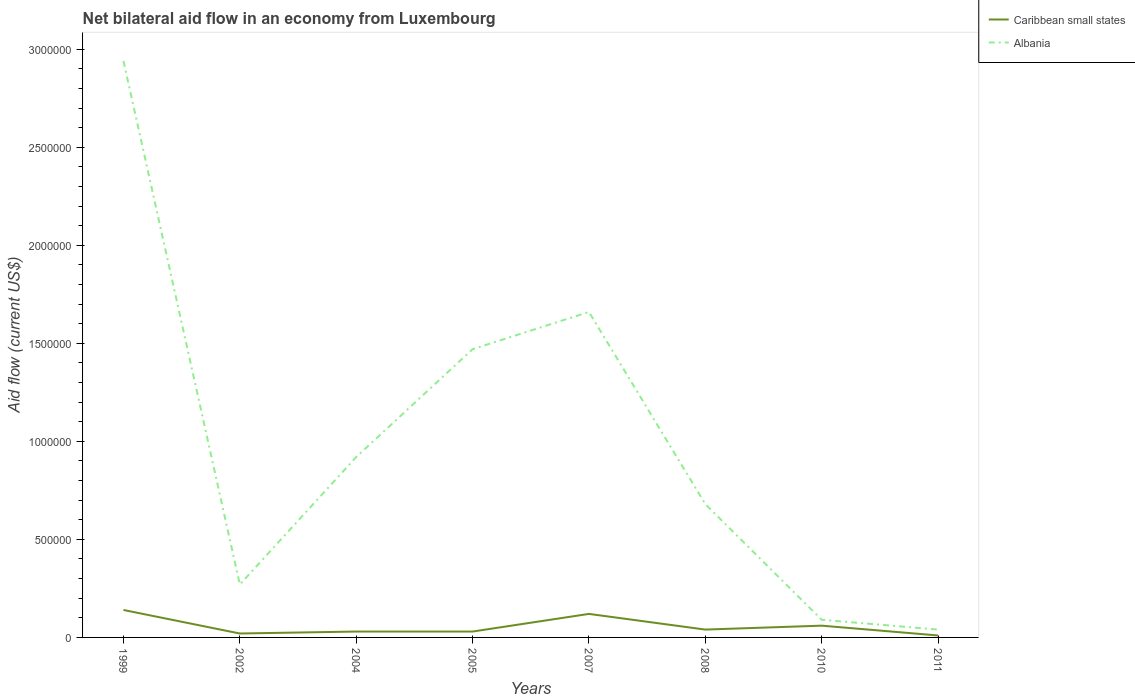Is the number of lines equal to the number of legend labels?
Your response must be concise. Yes. In which year was the net bilateral aid flow in Albania maximum?
Provide a short and direct response. 2011. What is the total net bilateral aid flow in Caribbean small states in the graph?
Ensure brevity in your answer.  -3.00e+04. What is the difference between the highest and the second highest net bilateral aid flow in Albania?
Offer a terse response. 2.90e+06. Is the net bilateral aid flow in Caribbean small states strictly greater than the net bilateral aid flow in Albania over the years?
Give a very brief answer. Yes. How many lines are there?
Your response must be concise. 2. Are the values on the major ticks of Y-axis written in scientific E-notation?
Provide a succinct answer. No. Where does the legend appear in the graph?
Your answer should be very brief. Top right. How are the legend labels stacked?
Your response must be concise. Vertical. What is the title of the graph?
Offer a very short reply. Net bilateral aid flow in an economy from Luxembourg. Does "Pakistan" appear as one of the legend labels in the graph?
Provide a short and direct response. No. What is the label or title of the X-axis?
Give a very brief answer. Years. What is the label or title of the Y-axis?
Your answer should be compact. Aid flow (current US$). What is the Aid flow (current US$) in Albania in 1999?
Ensure brevity in your answer.  2.94e+06. What is the Aid flow (current US$) in Albania in 2002?
Keep it short and to the point. 2.70e+05. What is the Aid flow (current US$) of Caribbean small states in 2004?
Ensure brevity in your answer.  3.00e+04. What is the Aid flow (current US$) in Albania in 2004?
Make the answer very short. 9.20e+05. What is the Aid flow (current US$) in Caribbean small states in 2005?
Keep it short and to the point. 3.00e+04. What is the Aid flow (current US$) in Albania in 2005?
Ensure brevity in your answer.  1.47e+06. What is the Aid flow (current US$) of Caribbean small states in 2007?
Give a very brief answer. 1.20e+05. What is the Aid flow (current US$) of Albania in 2007?
Ensure brevity in your answer.  1.66e+06. What is the Aid flow (current US$) in Albania in 2008?
Give a very brief answer. 6.80e+05. What is the Aid flow (current US$) of Caribbean small states in 2010?
Make the answer very short. 6.00e+04. What is the Aid flow (current US$) of Caribbean small states in 2011?
Make the answer very short. 10000. Across all years, what is the maximum Aid flow (current US$) of Albania?
Ensure brevity in your answer.  2.94e+06. Across all years, what is the minimum Aid flow (current US$) of Caribbean small states?
Offer a terse response. 10000. Across all years, what is the minimum Aid flow (current US$) in Albania?
Your answer should be very brief. 4.00e+04. What is the total Aid flow (current US$) of Albania in the graph?
Keep it short and to the point. 8.07e+06. What is the difference between the Aid flow (current US$) of Albania in 1999 and that in 2002?
Your answer should be compact. 2.67e+06. What is the difference between the Aid flow (current US$) of Caribbean small states in 1999 and that in 2004?
Give a very brief answer. 1.10e+05. What is the difference between the Aid flow (current US$) of Albania in 1999 and that in 2004?
Keep it short and to the point. 2.02e+06. What is the difference between the Aid flow (current US$) in Albania in 1999 and that in 2005?
Provide a short and direct response. 1.47e+06. What is the difference between the Aid flow (current US$) in Albania in 1999 and that in 2007?
Provide a succinct answer. 1.28e+06. What is the difference between the Aid flow (current US$) in Albania in 1999 and that in 2008?
Ensure brevity in your answer.  2.26e+06. What is the difference between the Aid flow (current US$) of Albania in 1999 and that in 2010?
Give a very brief answer. 2.85e+06. What is the difference between the Aid flow (current US$) in Caribbean small states in 1999 and that in 2011?
Your response must be concise. 1.30e+05. What is the difference between the Aid flow (current US$) of Albania in 1999 and that in 2011?
Your response must be concise. 2.90e+06. What is the difference between the Aid flow (current US$) in Caribbean small states in 2002 and that in 2004?
Offer a terse response. -10000. What is the difference between the Aid flow (current US$) of Albania in 2002 and that in 2004?
Provide a short and direct response. -6.50e+05. What is the difference between the Aid flow (current US$) of Caribbean small states in 2002 and that in 2005?
Ensure brevity in your answer.  -10000. What is the difference between the Aid flow (current US$) in Albania in 2002 and that in 2005?
Your response must be concise. -1.20e+06. What is the difference between the Aid flow (current US$) in Albania in 2002 and that in 2007?
Ensure brevity in your answer.  -1.39e+06. What is the difference between the Aid flow (current US$) in Albania in 2002 and that in 2008?
Offer a terse response. -4.10e+05. What is the difference between the Aid flow (current US$) in Caribbean small states in 2002 and that in 2011?
Make the answer very short. 10000. What is the difference between the Aid flow (current US$) of Albania in 2004 and that in 2005?
Provide a succinct answer. -5.50e+05. What is the difference between the Aid flow (current US$) in Albania in 2004 and that in 2007?
Give a very brief answer. -7.40e+05. What is the difference between the Aid flow (current US$) in Caribbean small states in 2004 and that in 2008?
Offer a terse response. -10000. What is the difference between the Aid flow (current US$) in Albania in 2004 and that in 2008?
Your response must be concise. 2.40e+05. What is the difference between the Aid flow (current US$) in Caribbean small states in 2004 and that in 2010?
Your response must be concise. -3.00e+04. What is the difference between the Aid flow (current US$) in Albania in 2004 and that in 2010?
Give a very brief answer. 8.30e+05. What is the difference between the Aid flow (current US$) of Albania in 2004 and that in 2011?
Offer a terse response. 8.80e+05. What is the difference between the Aid flow (current US$) of Albania in 2005 and that in 2007?
Offer a very short reply. -1.90e+05. What is the difference between the Aid flow (current US$) of Albania in 2005 and that in 2008?
Keep it short and to the point. 7.90e+05. What is the difference between the Aid flow (current US$) in Caribbean small states in 2005 and that in 2010?
Provide a succinct answer. -3.00e+04. What is the difference between the Aid flow (current US$) in Albania in 2005 and that in 2010?
Your answer should be compact. 1.38e+06. What is the difference between the Aid flow (current US$) in Caribbean small states in 2005 and that in 2011?
Offer a very short reply. 2.00e+04. What is the difference between the Aid flow (current US$) of Albania in 2005 and that in 2011?
Your answer should be compact. 1.43e+06. What is the difference between the Aid flow (current US$) in Albania in 2007 and that in 2008?
Offer a very short reply. 9.80e+05. What is the difference between the Aid flow (current US$) in Albania in 2007 and that in 2010?
Give a very brief answer. 1.57e+06. What is the difference between the Aid flow (current US$) of Caribbean small states in 2007 and that in 2011?
Keep it short and to the point. 1.10e+05. What is the difference between the Aid flow (current US$) in Albania in 2007 and that in 2011?
Keep it short and to the point. 1.62e+06. What is the difference between the Aid flow (current US$) in Albania in 2008 and that in 2010?
Your answer should be very brief. 5.90e+05. What is the difference between the Aid flow (current US$) in Caribbean small states in 2008 and that in 2011?
Your answer should be compact. 3.00e+04. What is the difference between the Aid flow (current US$) of Albania in 2008 and that in 2011?
Your answer should be compact. 6.40e+05. What is the difference between the Aid flow (current US$) of Caribbean small states in 2010 and that in 2011?
Your response must be concise. 5.00e+04. What is the difference between the Aid flow (current US$) in Albania in 2010 and that in 2011?
Provide a short and direct response. 5.00e+04. What is the difference between the Aid flow (current US$) in Caribbean small states in 1999 and the Aid flow (current US$) in Albania in 2002?
Ensure brevity in your answer.  -1.30e+05. What is the difference between the Aid flow (current US$) of Caribbean small states in 1999 and the Aid flow (current US$) of Albania in 2004?
Your response must be concise. -7.80e+05. What is the difference between the Aid flow (current US$) of Caribbean small states in 1999 and the Aid flow (current US$) of Albania in 2005?
Your response must be concise. -1.33e+06. What is the difference between the Aid flow (current US$) of Caribbean small states in 1999 and the Aid flow (current US$) of Albania in 2007?
Offer a terse response. -1.52e+06. What is the difference between the Aid flow (current US$) of Caribbean small states in 1999 and the Aid flow (current US$) of Albania in 2008?
Offer a very short reply. -5.40e+05. What is the difference between the Aid flow (current US$) of Caribbean small states in 1999 and the Aid flow (current US$) of Albania in 2010?
Keep it short and to the point. 5.00e+04. What is the difference between the Aid flow (current US$) in Caribbean small states in 1999 and the Aid flow (current US$) in Albania in 2011?
Give a very brief answer. 1.00e+05. What is the difference between the Aid flow (current US$) of Caribbean small states in 2002 and the Aid flow (current US$) of Albania in 2004?
Your response must be concise. -9.00e+05. What is the difference between the Aid flow (current US$) of Caribbean small states in 2002 and the Aid flow (current US$) of Albania in 2005?
Ensure brevity in your answer.  -1.45e+06. What is the difference between the Aid flow (current US$) of Caribbean small states in 2002 and the Aid flow (current US$) of Albania in 2007?
Give a very brief answer. -1.64e+06. What is the difference between the Aid flow (current US$) of Caribbean small states in 2002 and the Aid flow (current US$) of Albania in 2008?
Your answer should be compact. -6.60e+05. What is the difference between the Aid flow (current US$) of Caribbean small states in 2002 and the Aid flow (current US$) of Albania in 2010?
Provide a short and direct response. -7.00e+04. What is the difference between the Aid flow (current US$) in Caribbean small states in 2004 and the Aid flow (current US$) in Albania in 2005?
Offer a terse response. -1.44e+06. What is the difference between the Aid flow (current US$) in Caribbean small states in 2004 and the Aid flow (current US$) in Albania in 2007?
Your response must be concise. -1.63e+06. What is the difference between the Aid flow (current US$) in Caribbean small states in 2004 and the Aid flow (current US$) in Albania in 2008?
Keep it short and to the point. -6.50e+05. What is the difference between the Aid flow (current US$) in Caribbean small states in 2004 and the Aid flow (current US$) in Albania in 2011?
Make the answer very short. -10000. What is the difference between the Aid flow (current US$) of Caribbean small states in 2005 and the Aid flow (current US$) of Albania in 2007?
Provide a succinct answer. -1.63e+06. What is the difference between the Aid flow (current US$) in Caribbean small states in 2005 and the Aid flow (current US$) in Albania in 2008?
Your answer should be very brief. -6.50e+05. What is the difference between the Aid flow (current US$) of Caribbean small states in 2005 and the Aid flow (current US$) of Albania in 2010?
Offer a very short reply. -6.00e+04. What is the difference between the Aid flow (current US$) of Caribbean small states in 2005 and the Aid flow (current US$) of Albania in 2011?
Give a very brief answer. -10000. What is the difference between the Aid flow (current US$) in Caribbean small states in 2007 and the Aid flow (current US$) in Albania in 2008?
Your answer should be compact. -5.60e+05. What is the difference between the Aid flow (current US$) of Caribbean small states in 2007 and the Aid flow (current US$) of Albania in 2010?
Offer a terse response. 3.00e+04. What is the difference between the Aid flow (current US$) of Caribbean small states in 2008 and the Aid flow (current US$) of Albania in 2010?
Keep it short and to the point. -5.00e+04. What is the difference between the Aid flow (current US$) of Caribbean small states in 2010 and the Aid flow (current US$) of Albania in 2011?
Offer a very short reply. 2.00e+04. What is the average Aid flow (current US$) in Caribbean small states per year?
Offer a very short reply. 5.62e+04. What is the average Aid flow (current US$) of Albania per year?
Keep it short and to the point. 1.01e+06. In the year 1999, what is the difference between the Aid flow (current US$) of Caribbean small states and Aid flow (current US$) of Albania?
Offer a terse response. -2.80e+06. In the year 2004, what is the difference between the Aid flow (current US$) in Caribbean small states and Aid flow (current US$) in Albania?
Offer a terse response. -8.90e+05. In the year 2005, what is the difference between the Aid flow (current US$) in Caribbean small states and Aid flow (current US$) in Albania?
Provide a succinct answer. -1.44e+06. In the year 2007, what is the difference between the Aid flow (current US$) of Caribbean small states and Aid flow (current US$) of Albania?
Provide a short and direct response. -1.54e+06. In the year 2008, what is the difference between the Aid flow (current US$) in Caribbean small states and Aid flow (current US$) in Albania?
Offer a terse response. -6.40e+05. In the year 2010, what is the difference between the Aid flow (current US$) in Caribbean small states and Aid flow (current US$) in Albania?
Offer a very short reply. -3.00e+04. What is the ratio of the Aid flow (current US$) in Caribbean small states in 1999 to that in 2002?
Give a very brief answer. 7. What is the ratio of the Aid flow (current US$) of Albania in 1999 to that in 2002?
Provide a short and direct response. 10.89. What is the ratio of the Aid flow (current US$) of Caribbean small states in 1999 to that in 2004?
Offer a very short reply. 4.67. What is the ratio of the Aid flow (current US$) in Albania in 1999 to that in 2004?
Offer a terse response. 3.2. What is the ratio of the Aid flow (current US$) in Caribbean small states in 1999 to that in 2005?
Offer a terse response. 4.67. What is the ratio of the Aid flow (current US$) in Albania in 1999 to that in 2005?
Your answer should be compact. 2. What is the ratio of the Aid flow (current US$) in Caribbean small states in 1999 to that in 2007?
Your answer should be very brief. 1.17. What is the ratio of the Aid flow (current US$) of Albania in 1999 to that in 2007?
Your answer should be compact. 1.77. What is the ratio of the Aid flow (current US$) in Albania in 1999 to that in 2008?
Make the answer very short. 4.32. What is the ratio of the Aid flow (current US$) in Caribbean small states in 1999 to that in 2010?
Your answer should be compact. 2.33. What is the ratio of the Aid flow (current US$) in Albania in 1999 to that in 2010?
Offer a very short reply. 32.67. What is the ratio of the Aid flow (current US$) in Albania in 1999 to that in 2011?
Provide a succinct answer. 73.5. What is the ratio of the Aid flow (current US$) of Caribbean small states in 2002 to that in 2004?
Your response must be concise. 0.67. What is the ratio of the Aid flow (current US$) in Albania in 2002 to that in 2004?
Offer a terse response. 0.29. What is the ratio of the Aid flow (current US$) in Caribbean small states in 2002 to that in 2005?
Provide a short and direct response. 0.67. What is the ratio of the Aid flow (current US$) of Albania in 2002 to that in 2005?
Make the answer very short. 0.18. What is the ratio of the Aid flow (current US$) in Caribbean small states in 2002 to that in 2007?
Your answer should be compact. 0.17. What is the ratio of the Aid flow (current US$) of Albania in 2002 to that in 2007?
Keep it short and to the point. 0.16. What is the ratio of the Aid flow (current US$) of Caribbean small states in 2002 to that in 2008?
Your response must be concise. 0.5. What is the ratio of the Aid flow (current US$) of Albania in 2002 to that in 2008?
Your answer should be very brief. 0.4. What is the ratio of the Aid flow (current US$) of Albania in 2002 to that in 2010?
Give a very brief answer. 3. What is the ratio of the Aid flow (current US$) in Caribbean small states in 2002 to that in 2011?
Your answer should be very brief. 2. What is the ratio of the Aid flow (current US$) of Albania in 2002 to that in 2011?
Your response must be concise. 6.75. What is the ratio of the Aid flow (current US$) in Caribbean small states in 2004 to that in 2005?
Offer a terse response. 1. What is the ratio of the Aid flow (current US$) in Albania in 2004 to that in 2005?
Your answer should be very brief. 0.63. What is the ratio of the Aid flow (current US$) in Albania in 2004 to that in 2007?
Provide a succinct answer. 0.55. What is the ratio of the Aid flow (current US$) in Albania in 2004 to that in 2008?
Your answer should be compact. 1.35. What is the ratio of the Aid flow (current US$) of Albania in 2004 to that in 2010?
Keep it short and to the point. 10.22. What is the ratio of the Aid flow (current US$) of Caribbean small states in 2005 to that in 2007?
Your answer should be very brief. 0.25. What is the ratio of the Aid flow (current US$) in Albania in 2005 to that in 2007?
Offer a terse response. 0.89. What is the ratio of the Aid flow (current US$) in Caribbean small states in 2005 to that in 2008?
Your answer should be compact. 0.75. What is the ratio of the Aid flow (current US$) of Albania in 2005 to that in 2008?
Give a very brief answer. 2.16. What is the ratio of the Aid flow (current US$) of Caribbean small states in 2005 to that in 2010?
Offer a terse response. 0.5. What is the ratio of the Aid flow (current US$) of Albania in 2005 to that in 2010?
Offer a very short reply. 16.33. What is the ratio of the Aid flow (current US$) in Albania in 2005 to that in 2011?
Your answer should be compact. 36.75. What is the ratio of the Aid flow (current US$) in Caribbean small states in 2007 to that in 2008?
Offer a very short reply. 3. What is the ratio of the Aid flow (current US$) in Albania in 2007 to that in 2008?
Offer a terse response. 2.44. What is the ratio of the Aid flow (current US$) in Albania in 2007 to that in 2010?
Ensure brevity in your answer.  18.44. What is the ratio of the Aid flow (current US$) in Albania in 2007 to that in 2011?
Ensure brevity in your answer.  41.5. What is the ratio of the Aid flow (current US$) of Caribbean small states in 2008 to that in 2010?
Your response must be concise. 0.67. What is the ratio of the Aid flow (current US$) of Albania in 2008 to that in 2010?
Provide a succinct answer. 7.56. What is the ratio of the Aid flow (current US$) in Albania in 2008 to that in 2011?
Provide a short and direct response. 17. What is the ratio of the Aid flow (current US$) of Albania in 2010 to that in 2011?
Your answer should be very brief. 2.25. What is the difference between the highest and the second highest Aid flow (current US$) in Caribbean small states?
Give a very brief answer. 2.00e+04. What is the difference between the highest and the second highest Aid flow (current US$) in Albania?
Give a very brief answer. 1.28e+06. What is the difference between the highest and the lowest Aid flow (current US$) of Albania?
Your answer should be compact. 2.90e+06. 